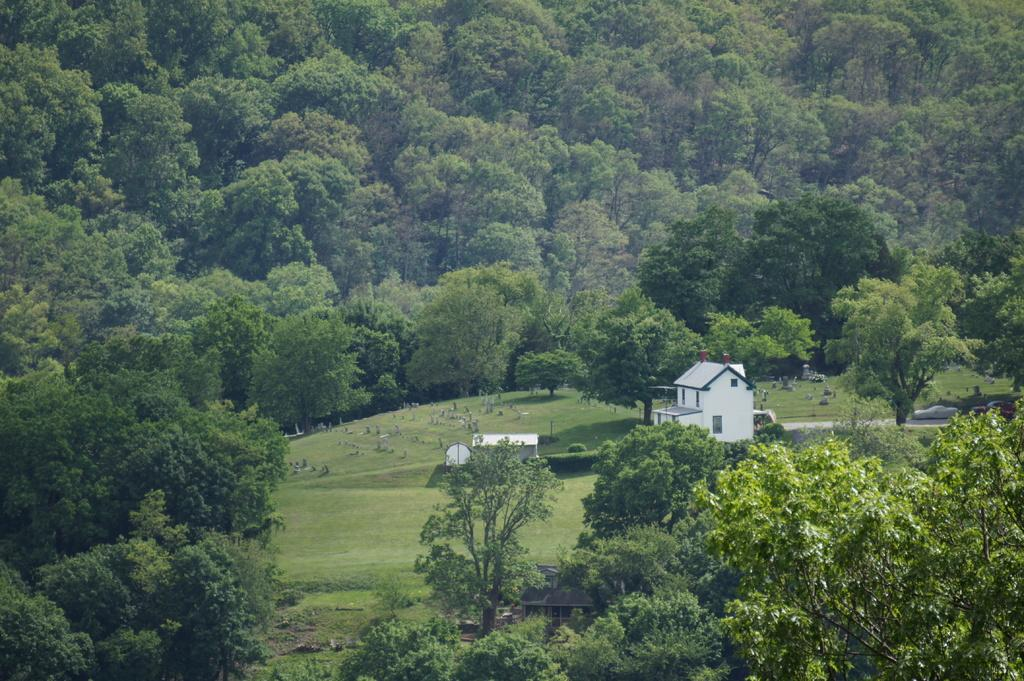What type of structure is present in the image? There is a building in the image. What other structures can be seen in the image? There are sheds in the image. What else is visible in the image besides structures? There are vehicles and objects on the ground in the image. What can be seen in the distance in the image? There are trees visible in the background of the image. What color is the copper wire used in the image? There is no copper wire present in the image. How many sides does the building have in the image? The number of sides of the building cannot be determined from the image alone, as only one side is visible. 